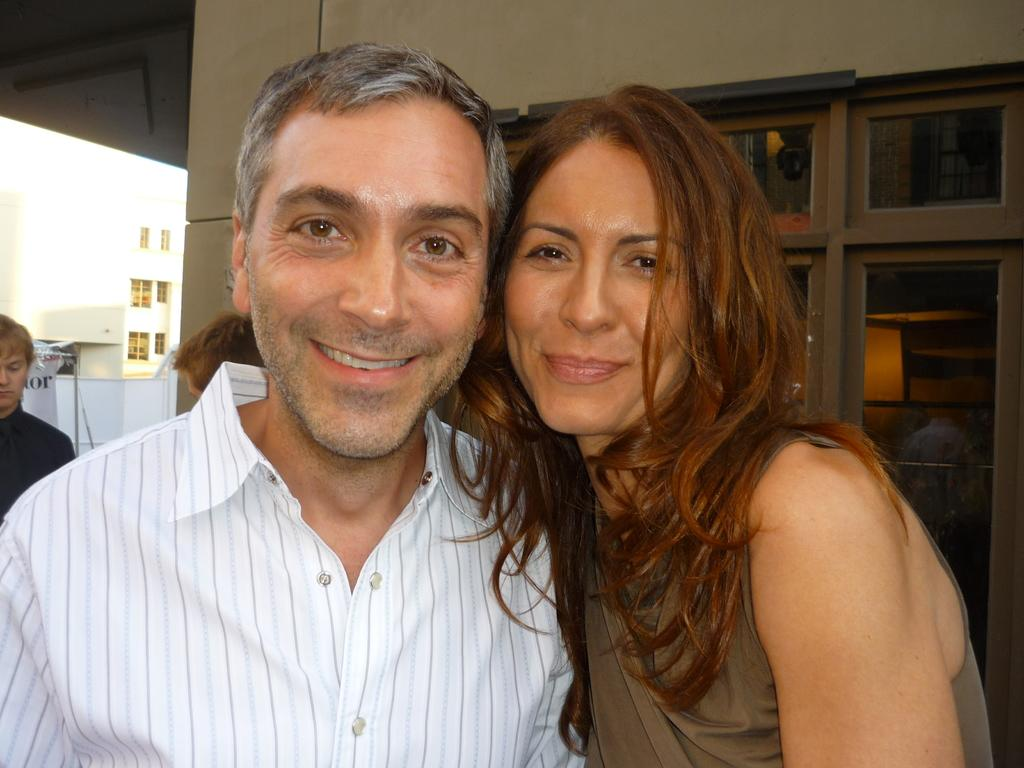What is located in front of the people in the image? There are no objects or structures in front of the people; they are standing in an open space. What can be seen behind the people in the image? There is a building behind the people in the image. Are there any other people visible in the image? Yes, there are other people standing at the back of the image. What type of coast can be seen in the image? There is no coast visible in the image; it features people standing in front of a building. What kind of smile is present on the building in the image? There is no smile present on the building in the image; it is a structure and does not have facial expressions. 